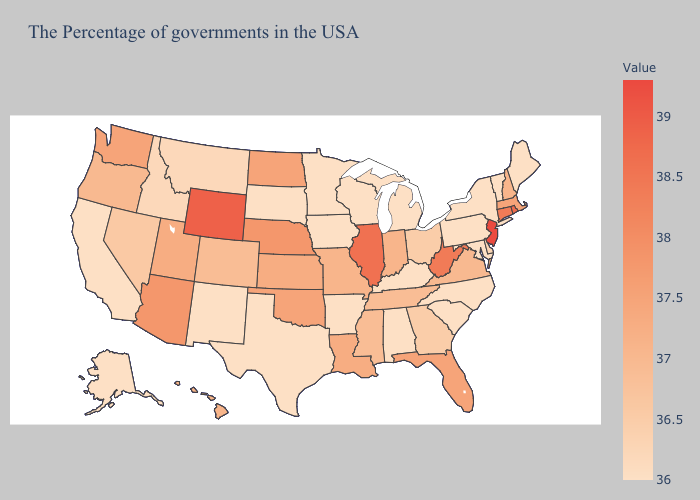Does the map have missing data?
Quick response, please. No. Which states hav the highest value in the South?
Quick response, please. West Virginia. Does the map have missing data?
Quick response, please. No. Is the legend a continuous bar?
Short answer required. Yes. Among the states that border Ohio , which have the highest value?
Concise answer only. West Virginia. Does Hawaii have a higher value than Nebraska?
Keep it brief. No. 